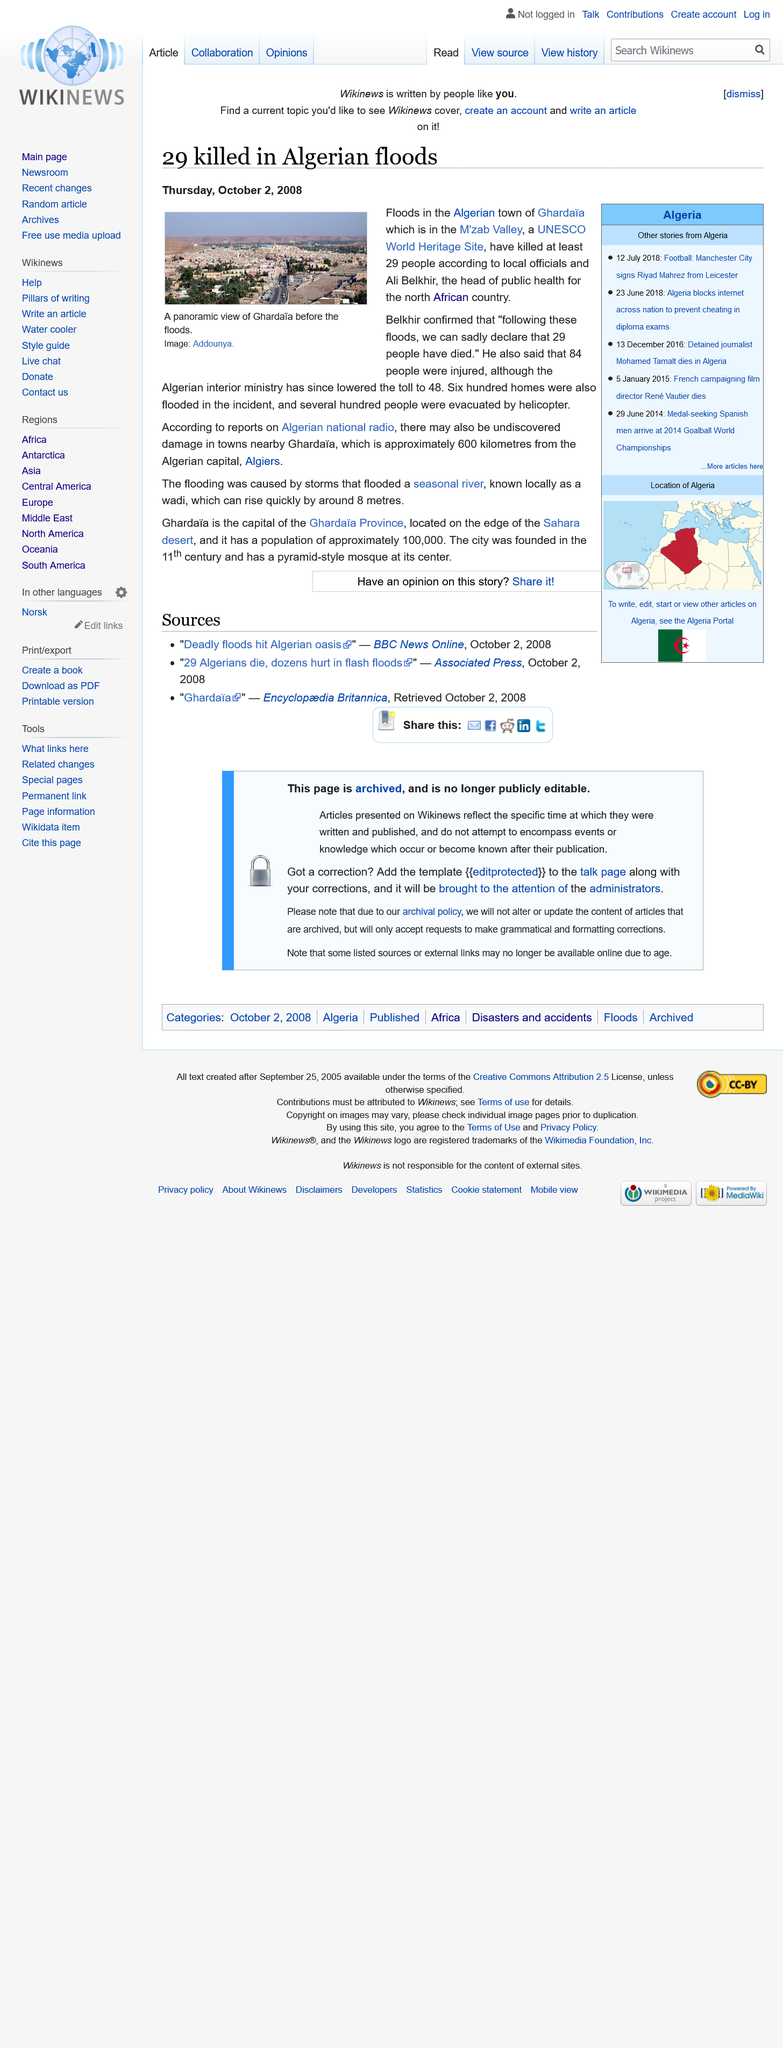Highlight a few significant elements in this photo. It is estimated that 600 homes were damaged in the recent floods. The image was taken before the flood. The floods took place in the country of Algeria. 